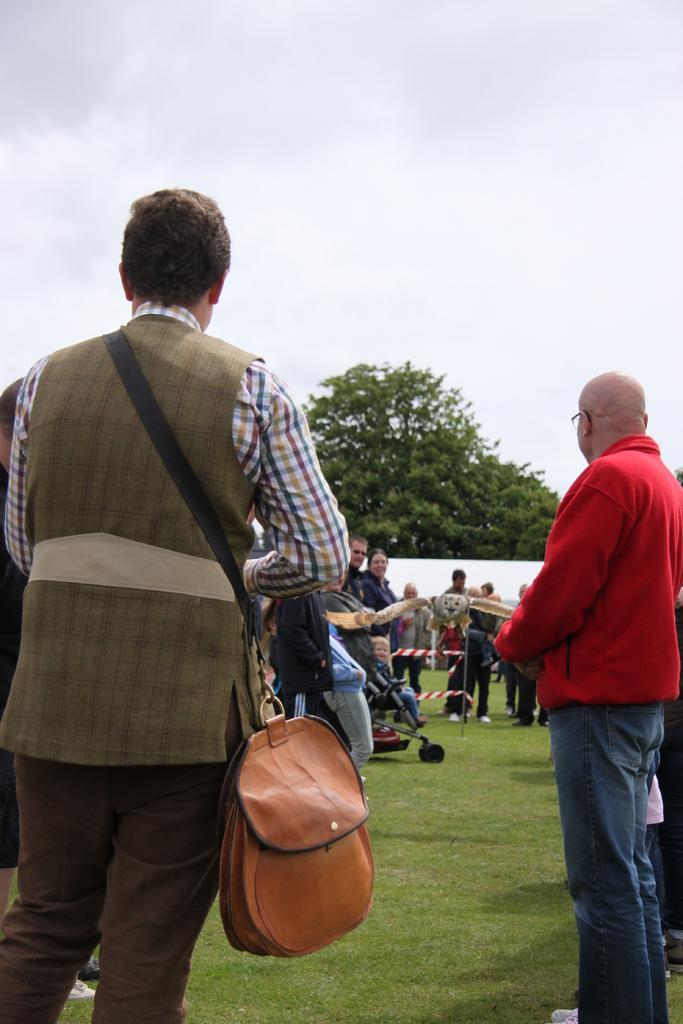In one or two sentences, can you explain what this image depicts? There is a group of people. They are standing. On the left side we have a person. He is wearing a bag. We can see in background trees and sky. 